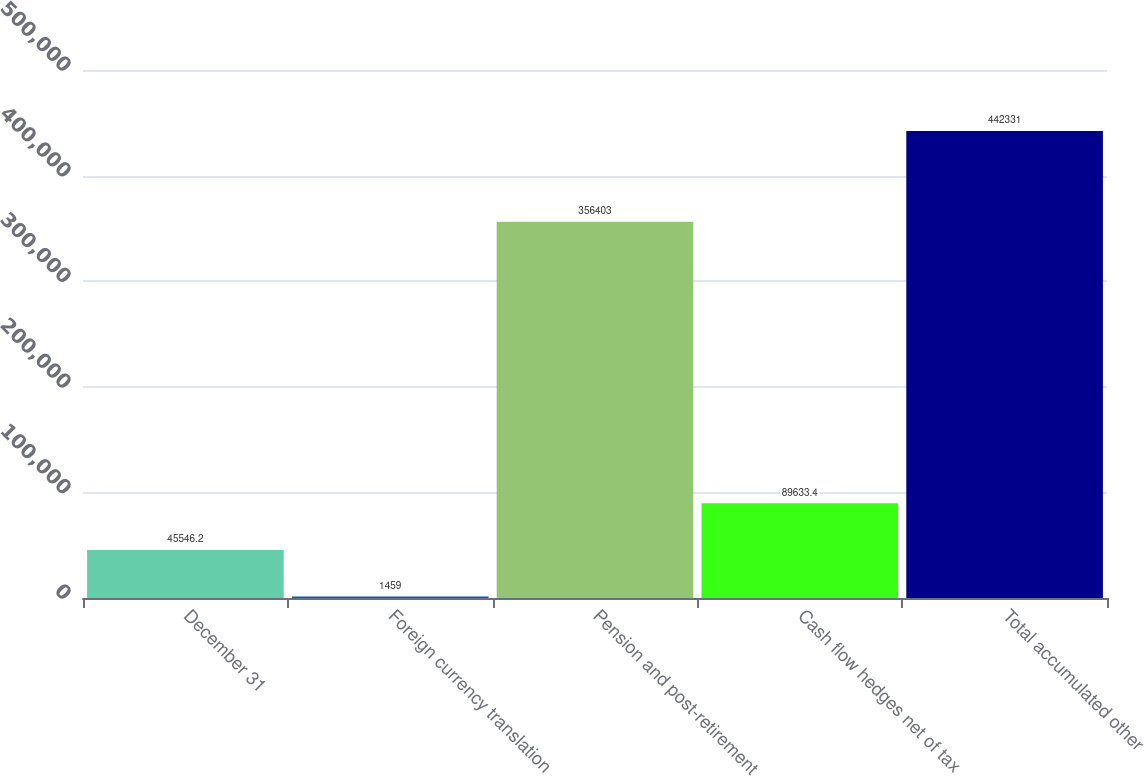<chart> <loc_0><loc_0><loc_500><loc_500><bar_chart><fcel>December 31<fcel>Foreign currency translation<fcel>Pension and post-retirement<fcel>Cash flow hedges net of tax<fcel>Total accumulated other<nl><fcel>45546.2<fcel>1459<fcel>356403<fcel>89633.4<fcel>442331<nl></chart> 